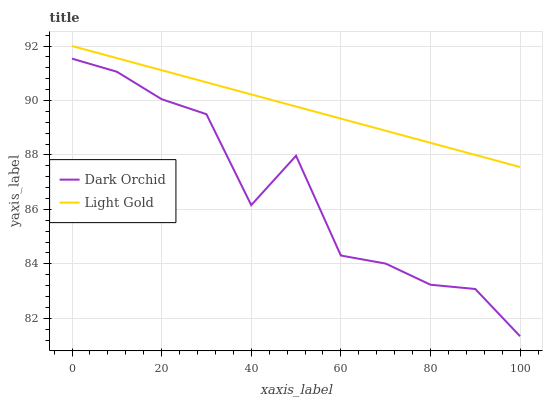Does Dark Orchid have the maximum area under the curve?
Answer yes or no. No. Is Dark Orchid the smoothest?
Answer yes or no. No. Does Dark Orchid have the highest value?
Answer yes or no. No. Is Dark Orchid less than Light Gold?
Answer yes or no. Yes. Is Light Gold greater than Dark Orchid?
Answer yes or no. Yes. Does Dark Orchid intersect Light Gold?
Answer yes or no. No. 